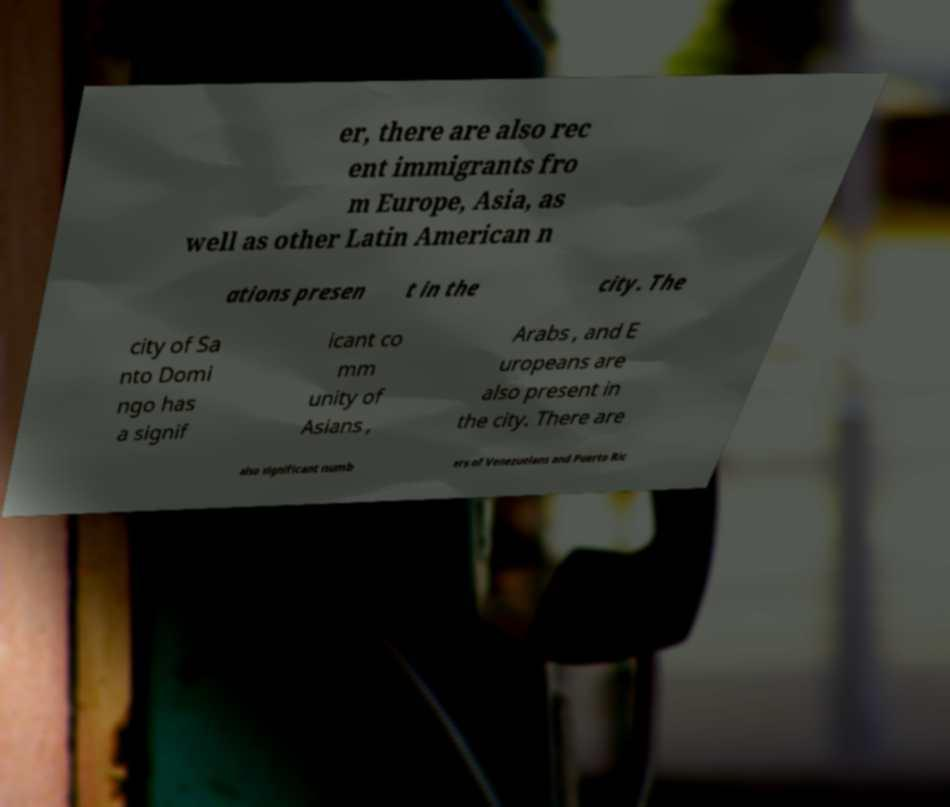What messages or text are displayed in this image? I need them in a readable, typed format. er, there are also rec ent immigrants fro m Europe, Asia, as well as other Latin American n ations presen t in the city. The city of Sa nto Domi ngo has a signif icant co mm unity of Asians , Arabs , and E uropeans are also present in the city. There are also significant numb ers of Venezuelans and Puerto Ric 